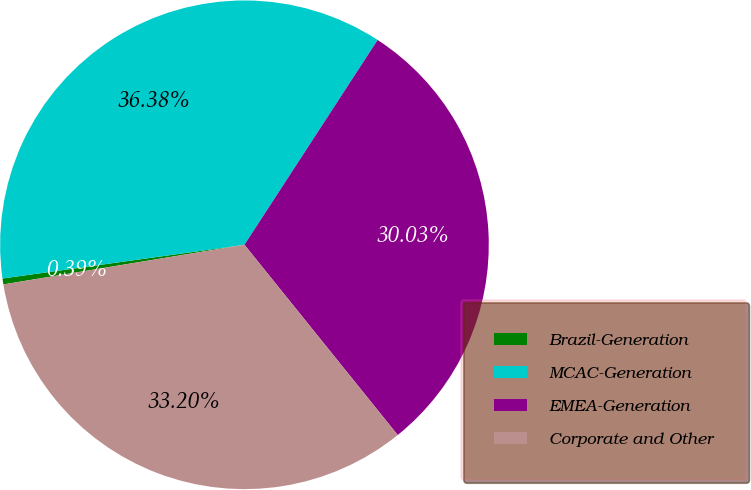Convert chart. <chart><loc_0><loc_0><loc_500><loc_500><pie_chart><fcel>Brazil-Generation<fcel>MCAC-Generation<fcel>EMEA-Generation<fcel>Corporate and Other<nl><fcel>0.39%<fcel>36.38%<fcel>30.03%<fcel>33.2%<nl></chart> 